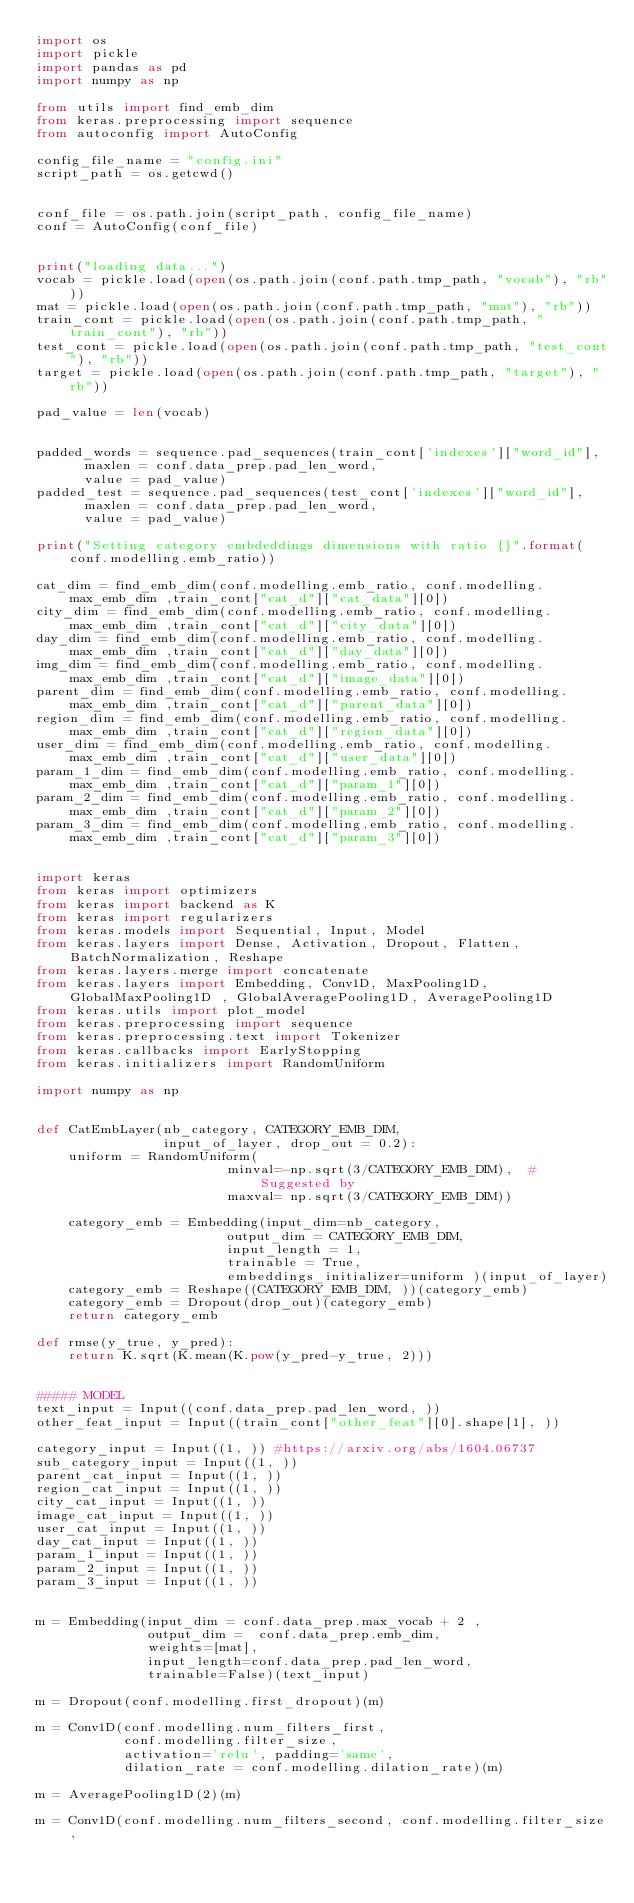Convert code to text. <code><loc_0><loc_0><loc_500><loc_500><_Python_>import os
import pickle
import pandas as pd
import numpy as np

from utils import find_emb_dim
from keras.preprocessing import sequence 
from autoconfig import AutoConfig

config_file_name = "config.ini"
script_path = os.getcwd()


conf_file = os.path.join(script_path, config_file_name)
conf = AutoConfig(conf_file)


print("loading data...")
vocab = pickle.load(open(os.path.join(conf.path.tmp_path, "vocab"), "rb"))
mat = pickle.load(open(os.path.join(conf.path.tmp_path, "mat"), "rb"))
train_cont = pickle.load(open(os.path.join(conf.path.tmp_path, "train_cont"), "rb"))
test_cont = pickle.load(open(os.path.join(conf.path.tmp_path, "test_cont"), "rb"))
target = pickle.load(open(os.path.join(conf.path.tmp_path, "target"), "rb"))

pad_value = len(vocab) 


padded_words = sequence.pad_sequences(train_cont['indexes']["word_id"],
      maxlen = conf.data_prep.pad_len_word, 
      value = pad_value)
padded_test = sequence.pad_sequences(test_cont['indexes']["word_id"],
      maxlen = conf.data_prep.pad_len_word,
      value = pad_value)

print("Setting category embdeddings dimensions with ratio {}".format(conf.modelling.emb_ratio))

cat_dim = find_emb_dim(conf.modelling.emb_ratio, conf.modelling.max_emb_dim ,train_cont["cat_d"]["cat_data"][0])
city_dim = find_emb_dim(conf.modelling.emb_ratio, conf.modelling.max_emb_dim ,train_cont["cat_d"]["city_data"][0])
day_dim = find_emb_dim(conf.modelling.emb_ratio, conf.modelling.max_emb_dim ,train_cont["cat_d"]["day_data"][0])
img_dim = find_emb_dim(conf.modelling.emb_ratio, conf.modelling.max_emb_dim ,train_cont["cat_d"]["image_data"][0])
parent_dim = find_emb_dim(conf.modelling.emb_ratio, conf.modelling.max_emb_dim ,train_cont["cat_d"]["parent_data"][0])
region_dim = find_emb_dim(conf.modelling.emb_ratio, conf.modelling.max_emb_dim ,train_cont["cat_d"]["region_data"][0])
user_dim = find_emb_dim(conf.modelling.emb_ratio, conf.modelling.max_emb_dim ,train_cont["cat_d"]["user_data"][0])
param_1_dim = find_emb_dim(conf.modelling.emb_ratio, conf.modelling.max_emb_dim ,train_cont["cat_d"]["param_1"][0])
param_2_dim = find_emb_dim(conf.modelling.emb_ratio, conf.modelling.max_emb_dim ,train_cont["cat_d"]["param_2"][0])
param_3_dim = find_emb_dim(conf.modelling.emb_ratio, conf.modelling.max_emb_dim ,train_cont["cat_d"]["param_3"][0])


import keras
from keras import optimizers
from keras import backend as K
from keras import regularizers
from keras.models import Sequential, Input, Model
from keras.layers import Dense, Activation, Dropout, Flatten, BatchNormalization, Reshape
from keras.layers.merge import concatenate
from keras.layers import Embedding, Conv1D, MaxPooling1D, GlobalMaxPooling1D , GlobalAveragePooling1D, AveragePooling1D
from keras.utils import plot_model
from keras.preprocessing import sequence
from keras.preprocessing.text import Tokenizer
from keras.callbacks import EarlyStopping
from keras.initializers import RandomUniform

import numpy as np


def CatEmbLayer(nb_category, CATEGORY_EMB_DIM,
                input_of_layer, drop_out = 0.2):
    uniform = RandomUniform(
                        minval=-np.sqrt(3/CATEGORY_EMB_DIM),  # Suggested by
                        maxval= np.sqrt(3/CATEGORY_EMB_DIM))
    
    category_emb = Embedding(input_dim=nb_category,
                        output_dim = CATEGORY_EMB_DIM,
                        input_length = 1,
                        trainable = True, 
                        embeddings_initializer=uniform )(input_of_layer)
    category_emb = Reshape((CATEGORY_EMB_DIM, ))(category_emb)
    category_emb = Dropout(drop_out)(category_emb)
    return category_emb

def rmse(y_true, y_pred):
    return K.sqrt(K.mean(K.pow(y_pred-y_true, 2)))


##### MODEL
text_input = Input((conf.data_prep.pad_len_word, ))
other_feat_input = Input((train_cont["other_feat"][0].shape[1], ))

category_input = Input((1, )) #https://arxiv.org/abs/1604.06737
sub_category_input = Input((1, ))
parent_cat_input = Input((1, ))
region_cat_input = Input((1, ))
city_cat_input = Input((1, ))
image_cat_input = Input((1, ))
user_cat_input = Input((1, ))
day_cat_input = Input((1, ))
param_1_input = Input((1, ))
param_2_input = Input((1, ))
param_3_input = Input((1, ))


m = Embedding(input_dim = conf.data_prep.max_vocab + 2 ,
              output_dim =  conf.data_prep.emb_dim,
              weights=[mat],
              input_length=conf.data_prep.pad_len_word,
              trainable=False)(text_input)

m = Dropout(conf.modelling.first_dropout)(m)

m = Conv1D(conf.modelling.num_filters_first,
           conf.modelling.filter_size,
           activation='relu', padding='same',
           dilation_rate = conf.modelling.dilation_rate)(m)

m = AveragePooling1D(2)(m)

m = Conv1D(conf.modelling.num_filters_second, conf.modelling.filter_size,</code> 